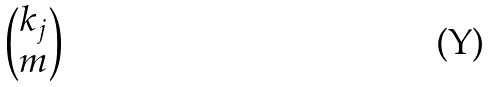<formula> <loc_0><loc_0><loc_500><loc_500>\begin{pmatrix} k _ { j } \\ m \end{pmatrix}</formula> 